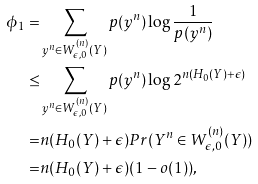Convert formula to latex. <formula><loc_0><loc_0><loc_500><loc_500>\phi _ { 1 } = & \sum _ { y ^ { n } \in W _ { \epsilon , 0 } ^ { ( n ) } ( Y ) } p ( y ^ { n } ) \log \frac { 1 } { p ( y ^ { n } ) } \\ \leq & \sum _ { y ^ { n } \in W _ { \epsilon , 0 } ^ { ( n ) } ( Y ) } p ( y ^ { n } ) \log 2 ^ { n ( H _ { 0 } ( Y ) + \epsilon ) } \\ = & n ( H _ { 0 } ( Y ) + \epsilon ) P r ( Y ^ { n } \in W _ { \epsilon , 0 } ^ { ( n ) } ( Y ) ) \\ = & n ( H _ { 0 } ( Y ) + \epsilon ) ( 1 - o ( 1 ) ) ,</formula> 